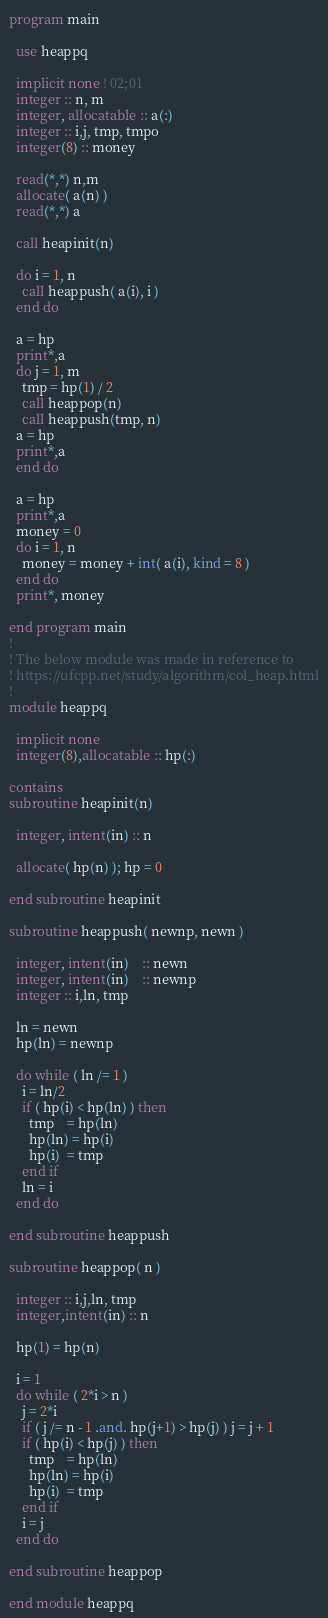<code> <loc_0><loc_0><loc_500><loc_500><_FORTRAN_>program main
  
  use heappq  

  implicit none ! 02;01
  integer :: n, m
  integer, allocatable :: a(:)
  integer :: i,j, tmp, tmpo
  integer(8) :: money
  
  read(*,*) n,m
  allocate( a(n) )
  read(*,*) a
  
  call heapinit(n)
  
  do i = 1, n
    call heappush( a(i), i )
  end do

  a = hp 
  print*,a
  do j = 1, m
    tmp = hp(1) / 2 
    call heappop(n)
    call heappush(tmp, n)
  a = hp 
  print*,a
  end do

  a = hp 
  print*,a
  money = 0
  do i = 1, n
    money = money + int( a(i), kind = 8 )
  end do
  print*, money

end program main
!
! The below module was made in reference to 
! https://ufcpp.net/study/algorithm/col_heap.html
!
module heappq
  
  implicit none
  integer(8),allocatable :: hp(:)

contains 
subroutine heapinit(n)
  
  integer, intent(in) :: n

  allocate( hp(n) ); hp = 0

end subroutine heapinit

subroutine heappush( newnp, newn )
  
  integer, intent(in)    :: newn
  integer, intent(in)    :: newnp
  integer :: i,ln, tmp
 
  ln = newn
  hp(ln) = newnp
  
  do while ( ln /= 1 )
    i = ln/2
    if ( hp(i) < hp(ln) ) then
      tmp    = hp(ln) 
      hp(ln) = hp(i) 
      hp(i)  = tmp 
    end if
    ln = i
  end do

end subroutine heappush

subroutine heappop( n )
  
  integer :: i,j,ln, tmp
  integer,intent(in) :: n
  
  hp(1) = hp(n)
  
  i = 1 
  do while ( 2*i > n )
    j = 2*i 
    if ( j /= n - 1 .and. hp(j+1) > hp(j) ) j = j + 1
    if ( hp(i) < hp(j) ) then
      tmp    = hp(ln) 
      hp(ln) = hp(i) 
      hp(i)  = tmp 
    end if
    i = j
  end do

end subroutine heappop
 
end module heappq
</code> 